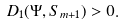Convert formula to latex. <formula><loc_0><loc_0><loc_500><loc_500>D _ { 1 } ( \Psi , S _ { m + 1 } ) > 0 .</formula> 